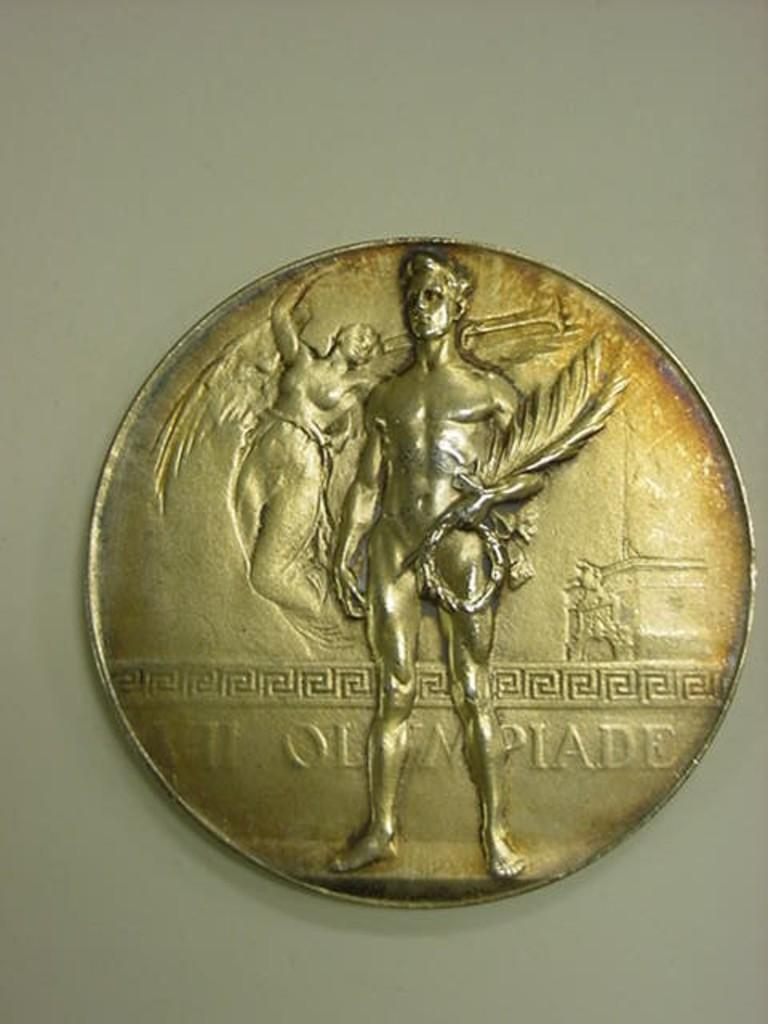<image>
Create a compact narrative representing the image presented. A gold colored coin has the world Olympiade stamped on it,. 